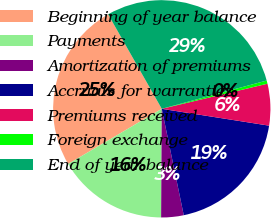<chart> <loc_0><loc_0><loc_500><loc_500><pie_chart><fcel>Beginning of year balance<fcel>Payments<fcel>Amortization of premiums<fcel>Accruals for warranties<fcel>Premiums received<fcel>Foreign exchange<fcel>End of year balance<nl><fcel>25.26%<fcel>16.43%<fcel>3.34%<fcel>19.28%<fcel>6.19%<fcel>0.48%<fcel>29.03%<nl></chart> 